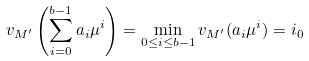Convert formula to latex. <formula><loc_0><loc_0><loc_500><loc_500>v _ { M ^ { \prime } } \left ( \sum _ { i = 0 } ^ { b - 1 } a _ { i } \mu ^ { i } \right ) = \min _ { 0 \leq i \leq b - 1 } v _ { M ^ { \prime } } ( a _ { i } \mu ^ { i } ) = i _ { 0 }</formula> 